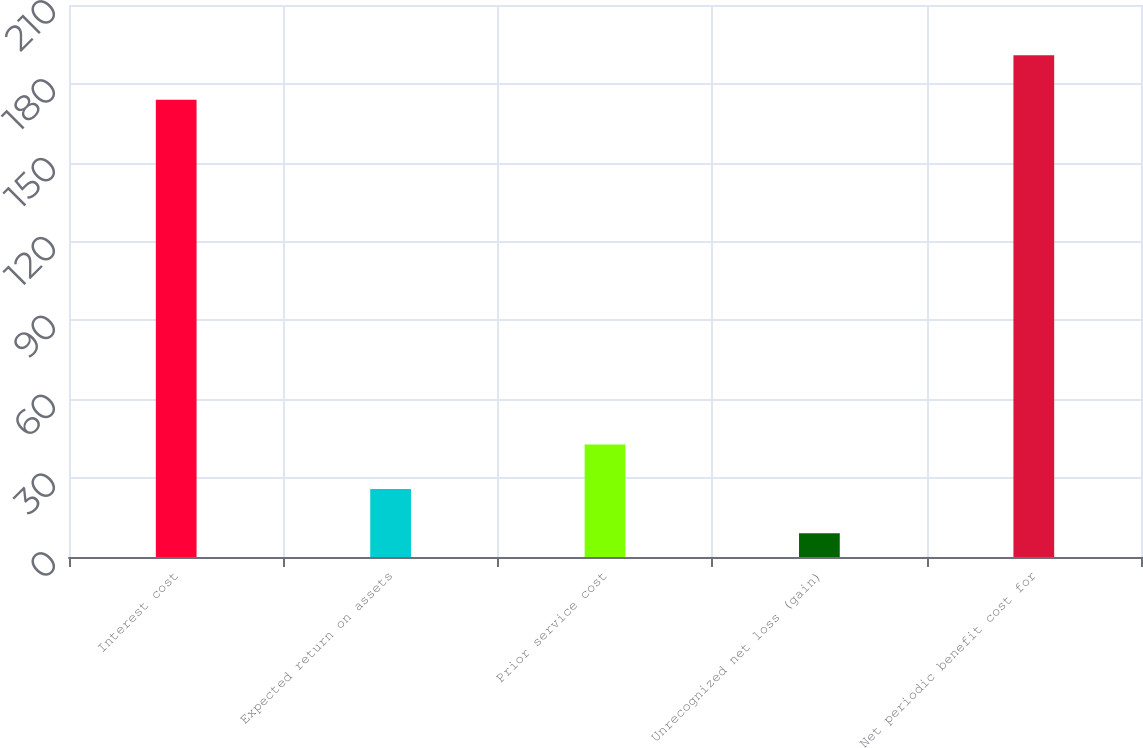<chart> <loc_0><loc_0><loc_500><loc_500><bar_chart><fcel>Interest cost<fcel>Expected return on assets<fcel>Prior service cost<fcel>Unrecognized net loss (gain)<fcel>Net periodic benefit cost for<nl><fcel>174<fcel>25.9<fcel>42.8<fcel>9<fcel>190.9<nl></chart> 